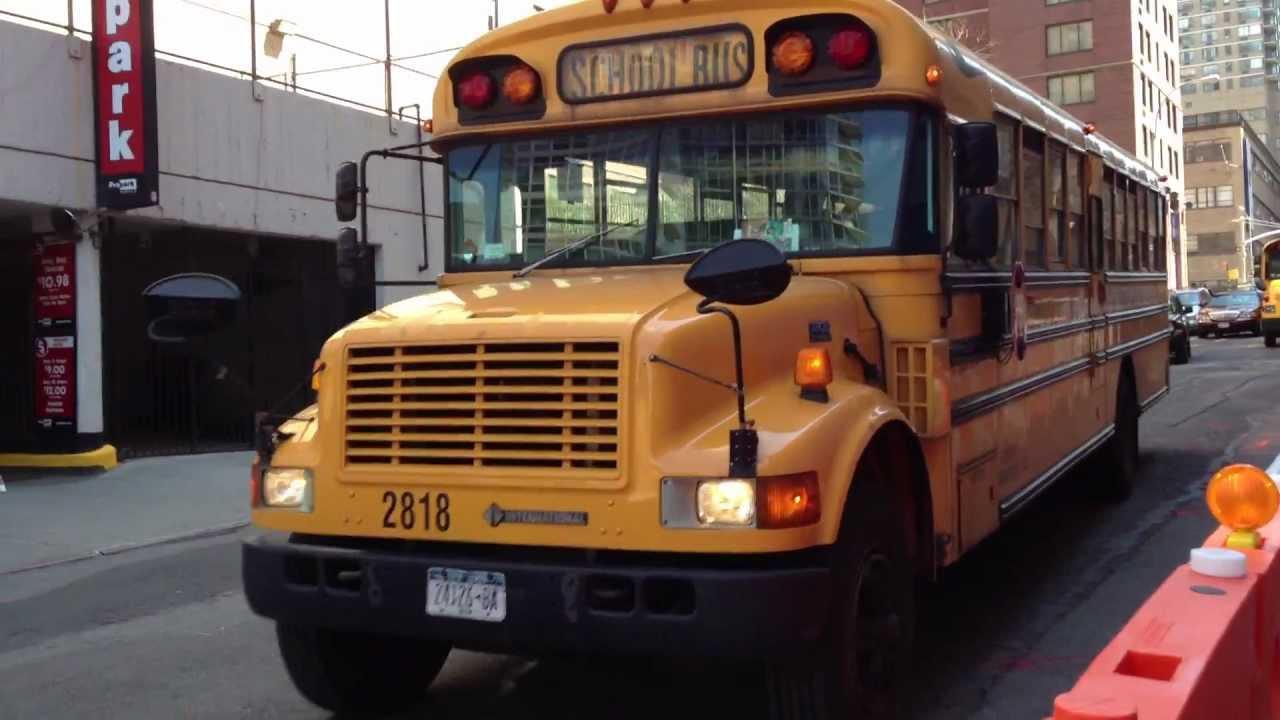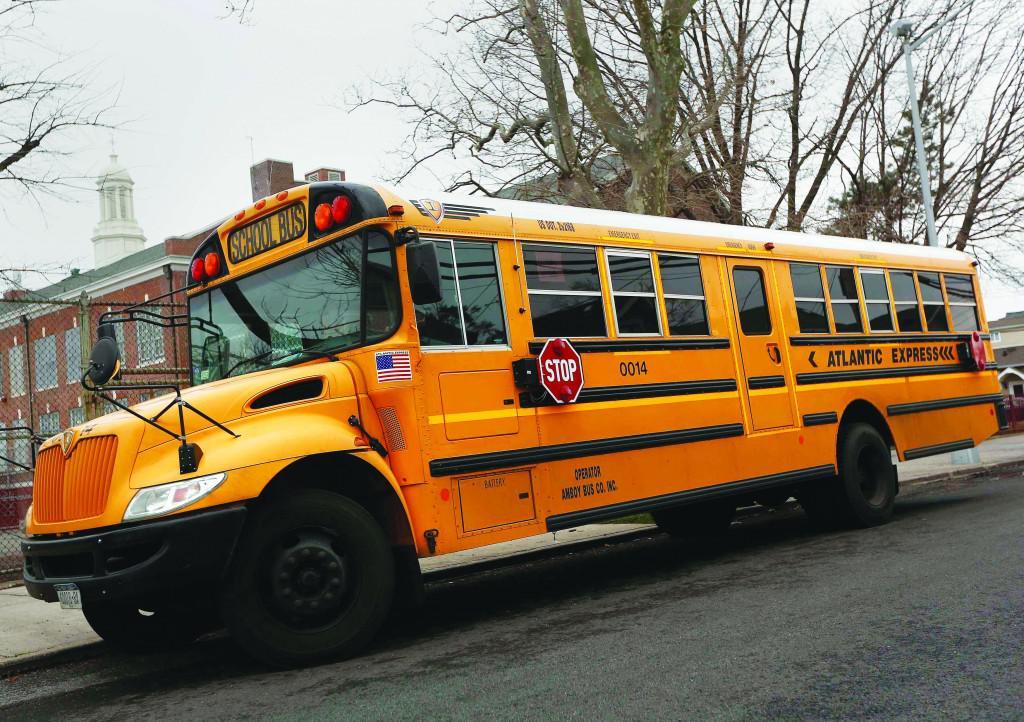The first image is the image on the left, the second image is the image on the right. Analyze the images presented: Is the assertion "The left image shows at least one bus heading away from the camera, and the right image shows at least one forward-angled bus." valid? Answer yes or no. No. The first image is the image on the left, the second image is the image on the right. Examine the images to the left and right. Is the description "In one of the images you can see the tail lights of a school bus." accurate? Answer yes or no. No. 